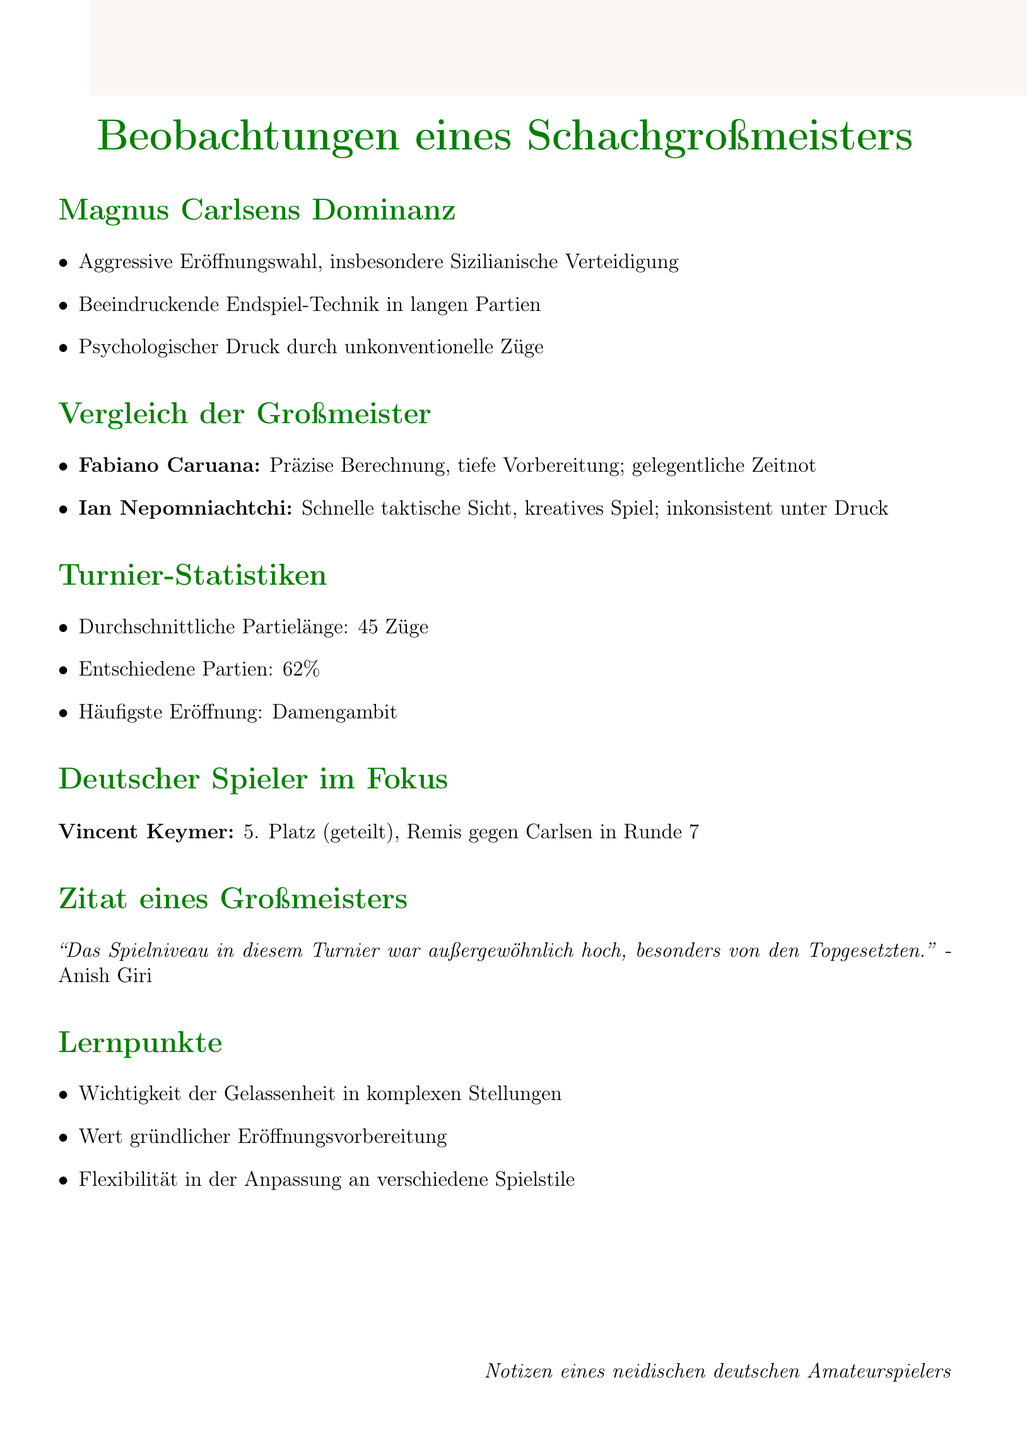What is the most common opening used in the tournament? The document states that the most common opening used was the Queen's Gambit.
Answer: Queen's Gambit Who tied for 5th place in the tournament? The document mentions that Vincent Keymer tied for 5th place in the tournament.
Answer: Vincent Keymer What quote did Anish Giri provide about the tournament? Anish Giri stated that "the level of play in this tournament has been exceptionally high, especially from the top seeds."
Answer: The level of play in this tournament has been exceptionally high, especially from the top seeds What percentage of the games were decisive? The document indicates that 62% of the games were decisive.
Answer: 62% What is one of Magnus Carlsen's strengths mentioned in the observations? The document highlights Carlsen's impressive endgame technique in long games as one of his strengths.
Answer: Impressive endgame technique in long games What is a noted weakness of Ian Nepomniachtchi? The document describes one of Nepomniachtchi's weaknesses as inconsistent performance under pressure.
Answer: Inconsistent performance under pressure 